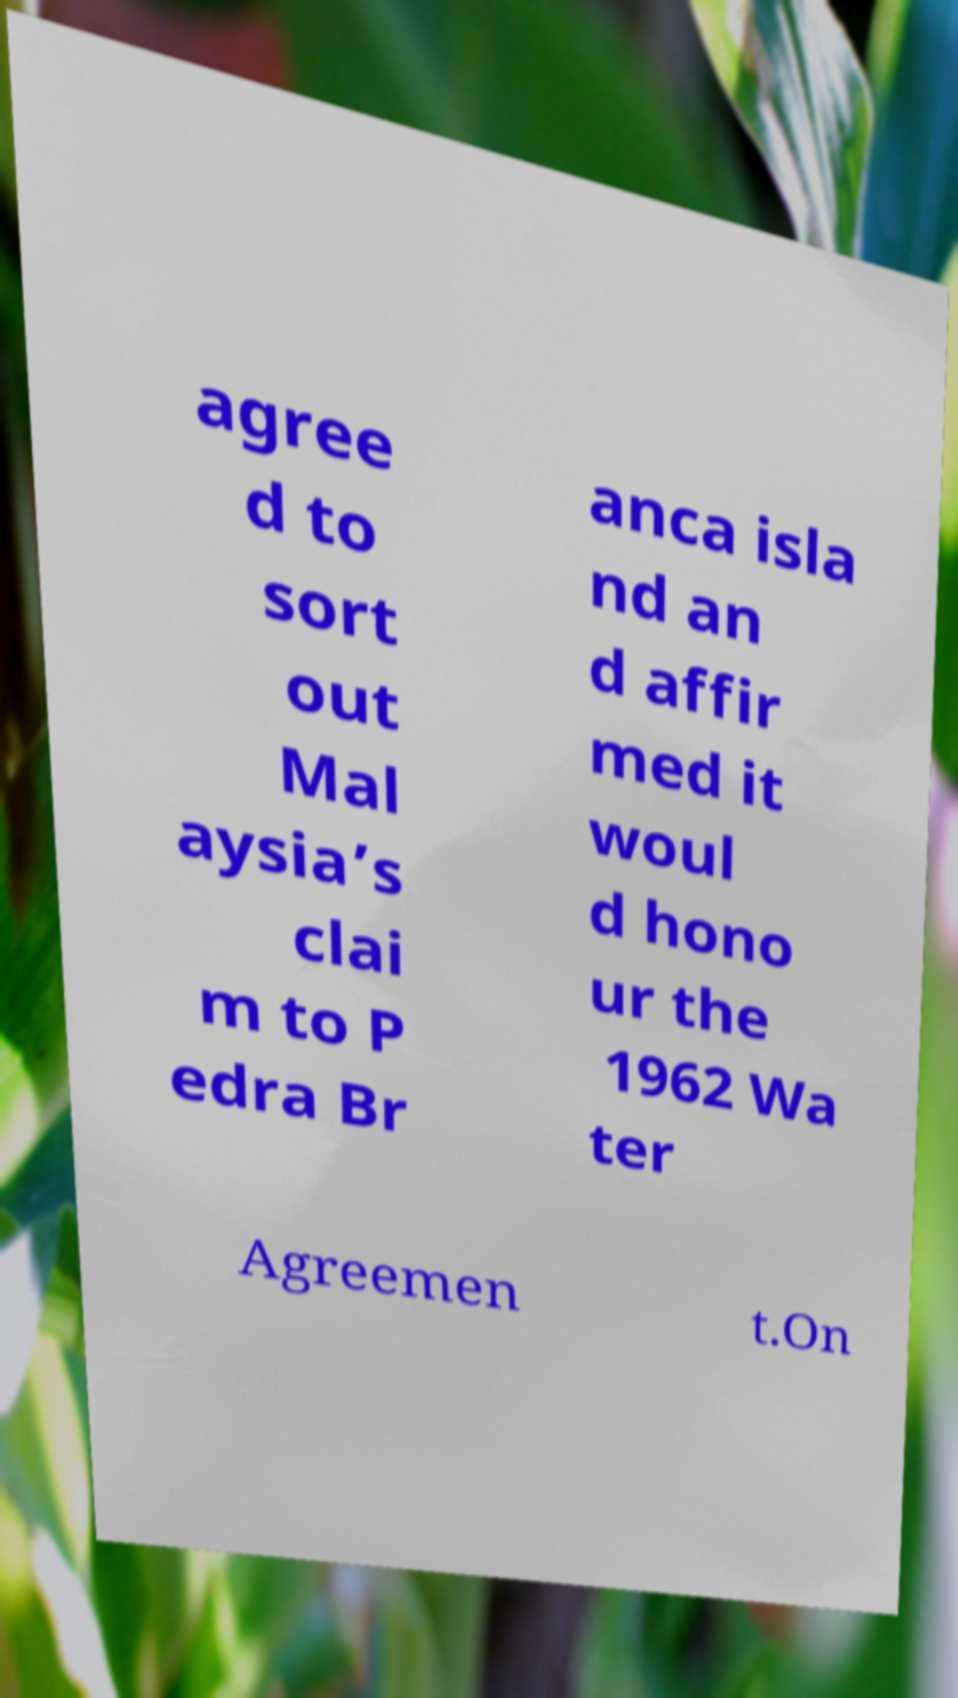Can you accurately transcribe the text from the provided image for me? agree d to sort out Mal aysia’s clai m to P edra Br anca isla nd an d affir med it woul d hono ur the 1962 Wa ter Agreemen t.On 